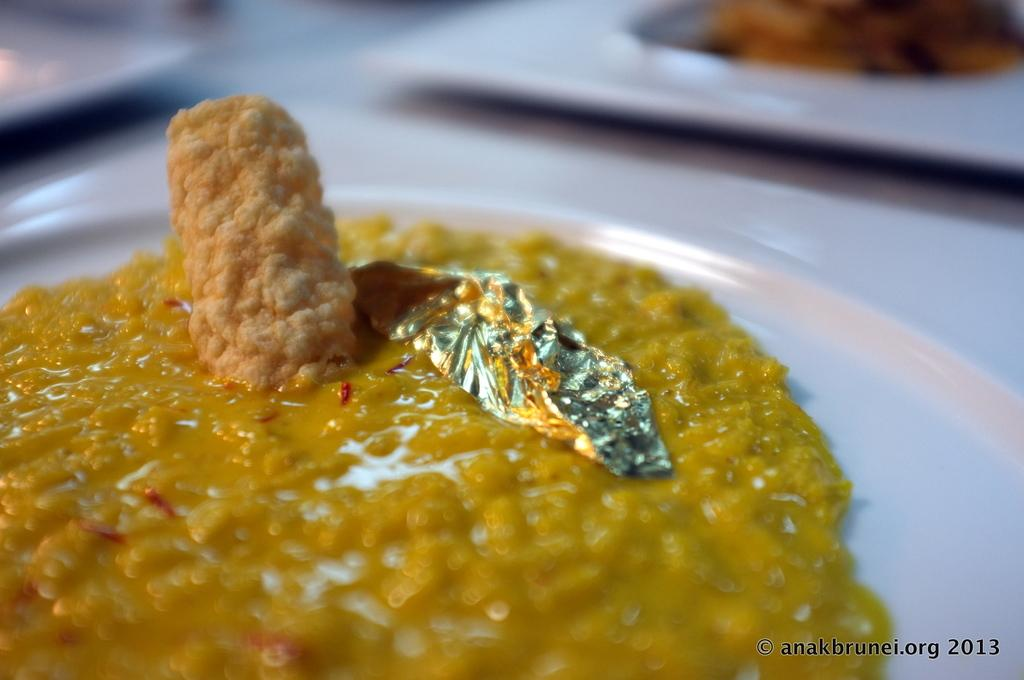What can be seen on the plates in the image? There are food items on plates in the image. Where are the plates located in the image? The plates are placed on a surface in the image. What type of sense can be seen in the image? There is no sense visible in the image; it features food items on plates placed on a surface. What type of crack is present in the image? There is no crack present in the image. 